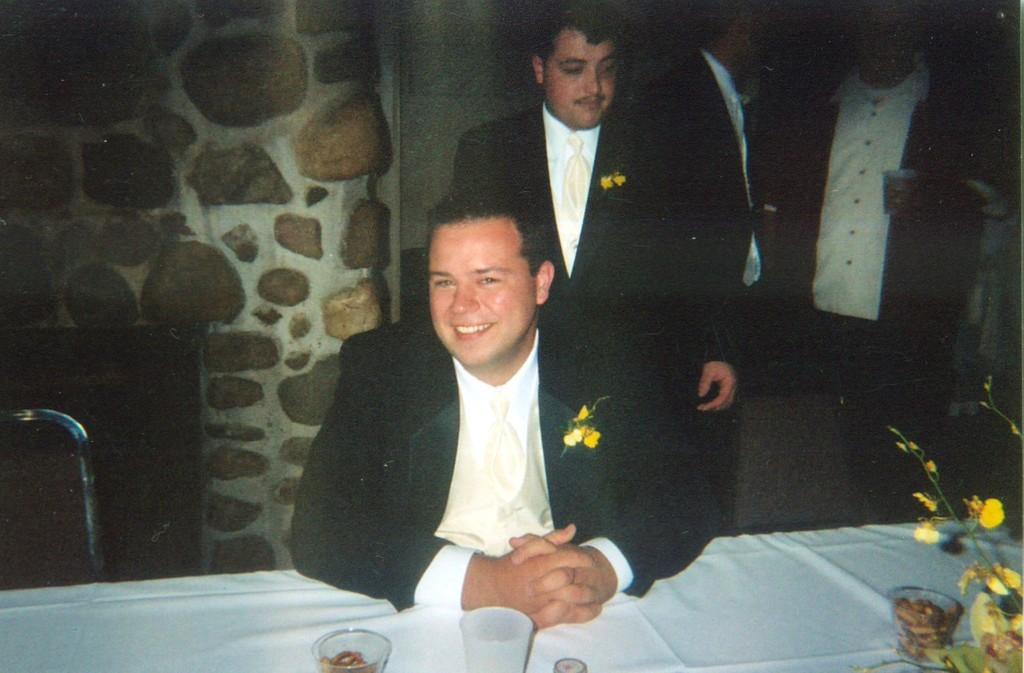Could you give a brief overview of what you see in this image? In this image we can see men standing on the floor and a man sitting on the chair. In the foreground we can see a table and on the table there are glass tumblers and flowers. In the background we can see wall build with cobblestones. 